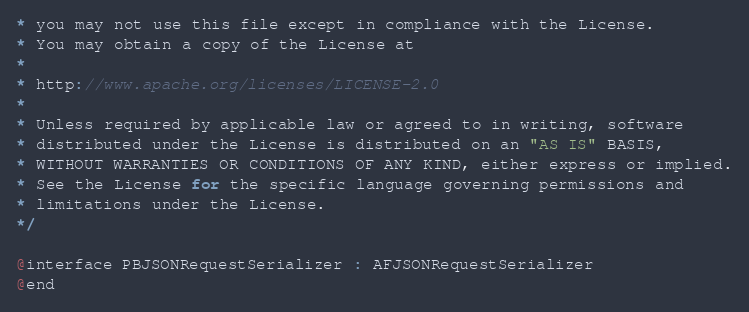Convert code to text. <code><loc_0><loc_0><loc_500><loc_500><_C_>* you may not use this file except in compliance with the License.
* You may obtain a copy of the License at
*
* http://www.apache.org/licenses/LICENSE-2.0
*
* Unless required by applicable law or agreed to in writing, software
* distributed under the License is distributed on an "AS IS" BASIS,
* WITHOUT WARRANTIES OR CONDITIONS OF ANY KIND, either express or implied.
* See the License for the specific language governing permissions and
* limitations under the License.
*/

@interface PBJSONRequestSerializer : AFJSONRequestSerializer
@end
</code> 